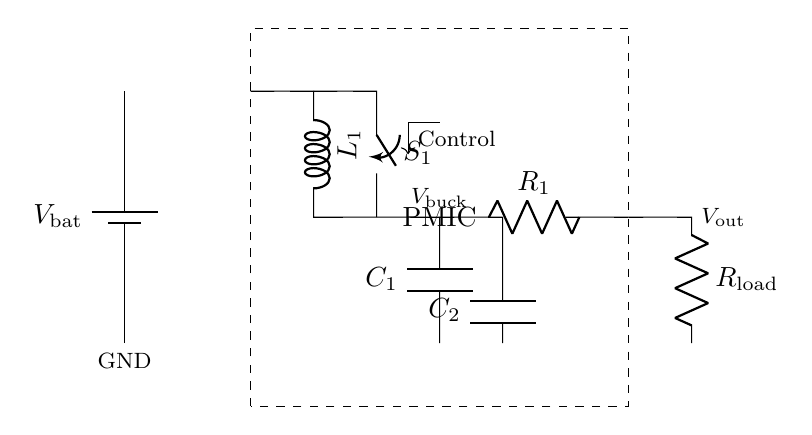What component is used for energy storage? The circuit includes a capacitor labeled as C1 which is connected after the buck converter, indicating its role in energy storage for filtering voltage.
Answer: Capacitor What is the purpose of the switch S1? The switch S1 is used to control the connection between the buck converter and the load, allowing for on/off operation to manage power delivery.
Answer: Control What does the PMIC stand for? PMIC stands for Power Management Integrated Circuit, which combines various power management functions to control voltage and current for the battery and load efficiently.
Answer: Power Management Integrated Circuit What is the function of the inductor L1? The inductor L1 in the buck converter design stores energy when the switch is closed and releases it when the switch is open, helping to regulate voltage output.
Answer: Energy regulation What is the output voltage labeled as? The output voltage is labeled as Vout, which represents the voltage delivered to the load from the PMIC output.
Answer: Vout How many capacitors are present in the circuit? There are two capacitors, C1 and C2, located in different parts of the circuit for filtering and energy storage purposes.
Answer: Two 